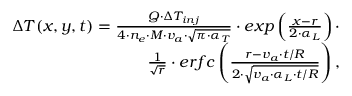Convert formula to latex. <formula><loc_0><loc_0><loc_500><loc_500>\begin{array} { r } { \Delta T ( x , y , t ) = \frac { Q \cdot \Delta T _ { i n j } } { 4 \cdot n _ { e } \cdot M \cdot v _ { a } \cdot \sqrt { \pi \cdot \alpha _ { T } } } \cdot e x p \left ( \frac { x - r } { 2 \cdot \alpha _ { L } } \right ) \cdot } \\ { \frac { 1 } { \sqrt { r } } \cdot e r f c \left ( \frac { r - v _ { a } \cdot t / R } { 2 \cdot \sqrt { v _ { a } \cdot \alpha _ { L } \cdot t / R } } \right ) , } \end{array}</formula> 